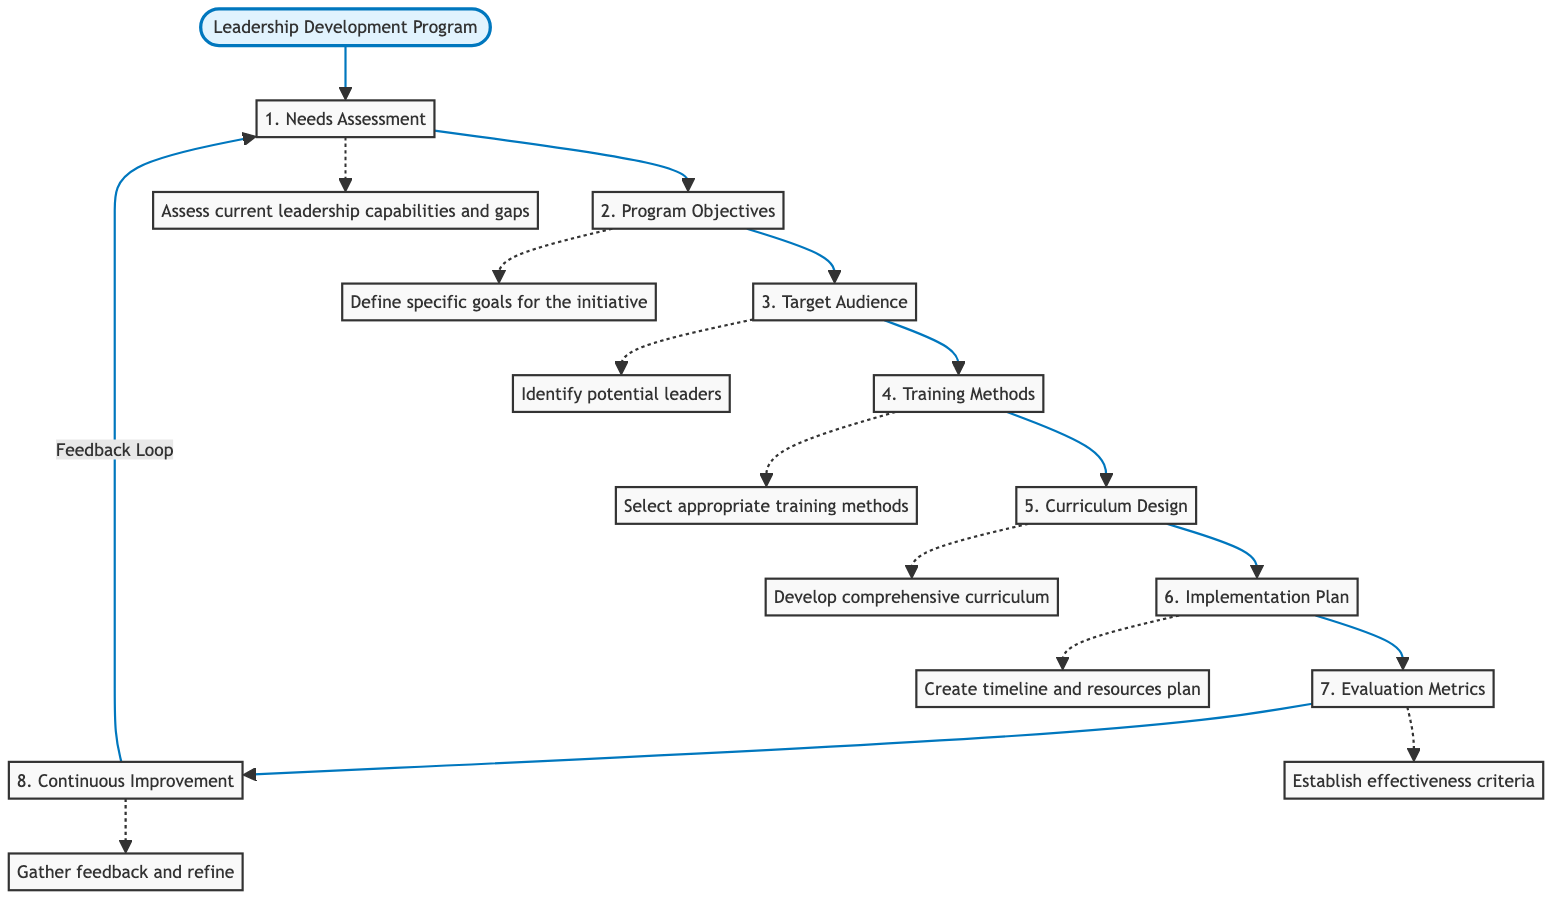What is the first step in the Leadership Development Program? The first step, as illustrated in the flow chart, is "Needs Assessment," which is the initial stage of the program.
Answer: Needs Assessment How many main steps are in the Leadership Development Program? The flow chart displays eight main steps from "Needs Assessment" to "Continuous Improvement," which indicates the total number of steps in the program.
Answer: Eight Which step follows "Training Methods"? According to the diagram, "Curriculum Design" is the step that directly follows "Training Methods" in the sequence of the program.
Answer: Curriculum Design What do the dotted lines in the diagram represent? The dotted lines indicate feedback loops, suggesting that there is an iterative process in the program, particularly regarding the "Continuous Improvement" stage leading back to "Needs Assessment."
Answer: Feedback loops What is the main goal of the "Evaluation Metrics" step? The goal defined for the "Evaluation Metrics" step is to measure the effectiveness and impact of the leadership development program, as shown in the flow chart.
Answer: Measure effectiveness Which step involves identifying potential leaders? The “Target Audience” step focuses on identifying potential leaders, which is clearly labeled in the flow chart as step three.
Answer: Target Audience How does the "Continuous Improvement" step relate to the "Needs Assessment"? The "Continuous Improvement" step has a feedback loop that connects back to "Needs Assessment," indicating that insights gained from this step are used to reassess leadership needs.
Answer: Feedback connection What action is described in the "Implementation Plan"? The "Implementation Plan" step involves creating a timeline and resources needed for program rollout, per the detailed description in the flow chart.
Answer: Create timeline and resources plan 